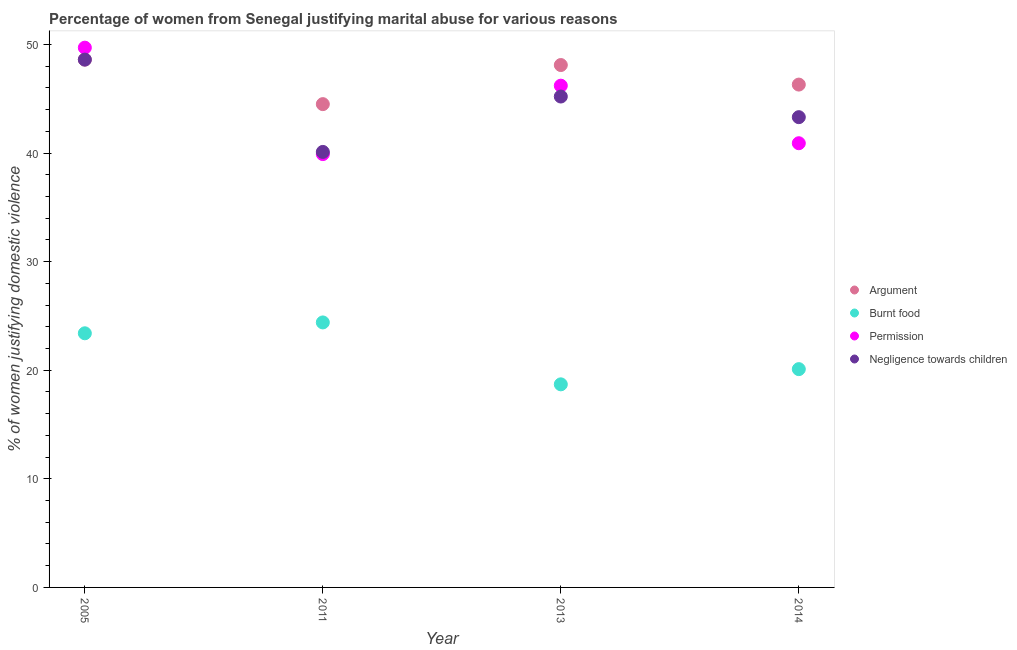What is the percentage of women justifying abuse in the case of an argument in 2011?
Provide a short and direct response. 44.5. Across all years, what is the maximum percentage of women justifying abuse for showing negligence towards children?
Provide a short and direct response. 48.6. Across all years, what is the minimum percentage of women justifying abuse in the case of an argument?
Offer a terse response. 44.5. In which year was the percentage of women justifying abuse for showing negligence towards children minimum?
Keep it short and to the point. 2011. What is the total percentage of women justifying abuse for going without permission in the graph?
Your answer should be very brief. 176.7. What is the difference between the percentage of women justifying abuse for going without permission in 2005 and that in 2014?
Keep it short and to the point. 8.8. What is the difference between the percentage of women justifying abuse for going without permission in 2014 and the percentage of women justifying abuse for burning food in 2013?
Offer a terse response. 22.2. What is the average percentage of women justifying abuse for showing negligence towards children per year?
Give a very brief answer. 44.3. In the year 2014, what is the difference between the percentage of women justifying abuse for showing negligence towards children and percentage of women justifying abuse for burning food?
Offer a very short reply. 23.2. What is the ratio of the percentage of women justifying abuse for going without permission in 2013 to that in 2014?
Make the answer very short. 1.13. Is the percentage of women justifying abuse in the case of an argument in 2013 less than that in 2014?
Your response must be concise. No. Is the difference between the percentage of women justifying abuse for showing negligence towards children in 2005 and 2011 greater than the difference between the percentage of women justifying abuse in the case of an argument in 2005 and 2011?
Keep it short and to the point. Yes. What is the difference between the highest and the second highest percentage of women justifying abuse for showing negligence towards children?
Provide a succinct answer. 3.4. Is the sum of the percentage of women justifying abuse in the case of an argument in 2013 and 2014 greater than the maximum percentage of women justifying abuse for showing negligence towards children across all years?
Your answer should be compact. Yes. Is it the case that in every year, the sum of the percentage of women justifying abuse in the case of an argument and percentage of women justifying abuse for showing negligence towards children is greater than the sum of percentage of women justifying abuse for burning food and percentage of women justifying abuse for going without permission?
Your response must be concise. No. Is the percentage of women justifying abuse for showing negligence towards children strictly greater than the percentage of women justifying abuse for going without permission over the years?
Provide a short and direct response. No. Is the percentage of women justifying abuse for showing negligence towards children strictly less than the percentage of women justifying abuse in the case of an argument over the years?
Your answer should be compact. No. How many years are there in the graph?
Offer a very short reply. 4. Are the values on the major ticks of Y-axis written in scientific E-notation?
Provide a short and direct response. No. Does the graph contain grids?
Provide a succinct answer. No. Where does the legend appear in the graph?
Your answer should be very brief. Center right. How are the legend labels stacked?
Provide a short and direct response. Vertical. What is the title of the graph?
Make the answer very short. Percentage of women from Senegal justifying marital abuse for various reasons. Does "International Monetary Fund" appear as one of the legend labels in the graph?
Offer a very short reply. No. What is the label or title of the X-axis?
Your response must be concise. Year. What is the label or title of the Y-axis?
Provide a succinct answer. % of women justifying domestic violence. What is the % of women justifying domestic violence in Argument in 2005?
Ensure brevity in your answer.  48.6. What is the % of women justifying domestic violence in Burnt food in 2005?
Keep it short and to the point. 23.4. What is the % of women justifying domestic violence in Permission in 2005?
Offer a terse response. 49.7. What is the % of women justifying domestic violence of Negligence towards children in 2005?
Give a very brief answer. 48.6. What is the % of women justifying domestic violence of Argument in 2011?
Your answer should be compact. 44.5. What is the % of women justifying domestic violence of Burnt food in 2011?
Your answer should be compact. 24.4. What is the % of women justifying domestic violence of Permission in 2011?
Your answer should be compact. 39.9. What is the % of women justifying domestic violence of Negligence towards children in 2011?
Ensure brevity in your answer.  40.1. What is the % of women justifying domestic violence in Argument in 2013?
Ensure brevity in your answer.  48.1. What is the % of women justifying domestic violence in Permission in 2013?
Your answer should be very brief. 46.2. What is the % of women justifying domestic violence of Negligence towards children in 2013?
Keep it short and to the point. 45.2. What is the % of women justifying domestic violence of Argument in 2014?
Your answer should be very brief. 46.3. What is the % of women justifying domestic violence in Burnt food in 2014?
Provide a short and direct response. 20.1. What is the % of women justifying domestic violence of Permission in 2014?
Your answer should be compact. 40.9. What is the % of women justifying domestic violence in Negligence towards children in 2014?
Your answer should be very brief. 43.3. Across all years, what is the maximum % of women justifying domestic violence of Argument?
Provide a succinct answer. 48.6. Across all years, what is the maximum % of women justifying domestic violence in Burnt food?
Keep it short and to the point. 24.4. Across all years, what is the maximum % of women justifying domestic violence of Permission?
Ensure brevity in your answer.  49.7. Across all years, what is the maximum % of women justifying domestic violence in Negligence towards children?
Provide a short and direct response. 48.6. Across all years, what is the minimum % of women justifying domestic violence of Argument?
Provide a succinct answer. 44.5. Across all years, what is the minimum % of women justifying domestic violence in Burnt food?
Offer a very short reply. 18.7. Across all years, what is the minimum % of women justifying domestic violence in Permission?
Make the answer very short. 39.9. Across all years, what is the minimum % of women justifying domestic violence in Negligence towards children?
Ensure brevity in your answer.  40.1. What is the total % of women justifying domestic violence in Argument in the graph?
Keep it short and to the point. 187.5. What is the total % of women justifying domestic violence of Burnt food in the graph?
Your response must be concise. 86.6. What is the total % of women justifying domestic violence of Permission in the graph?
Your answer should be compact. 176.7. What is the total % of women justifying domestic violence of Negligence towards children in the graph?
Keep it short and to the point. 177.2. What is the difference between the % of women justifying domestic violence of Argument in 2005 and that in 2011?
Keep it short and to the point. 4.1. What is the difference between the % of women justifying domestic violence in Permission in 2005 and that in 2011?
Make the answer very short. 9.8. What is the difference between the % of women justifying domestic violence of Burnt food in 2005 and that in 2013?
Ensure brevity in your answer.  4.7. What is the difference between the % of women justifying domestic violence of Permission in 2005 and that in 2013?
Provide a short and direct response. 3.5. What is the difference between the % of women justifying domestic violence in Argument in 2005 and that in 2014?
Your answer should be very brief. 2.3. What is the difference between the % of women justifying domestic violence in Negligence towards children in 2005 and that in 2014?
Your response must be concise. 5.3. What is the difference between the % of women justifying domestic violence of Argument in 2011 and that in 2013?
Offer a terse response. -3.6. What is the difference between the % of women justifying domestic violence of Burnt food in 2011 and that in 2013?
Provide a short and direct response. 5.7. What is the difference between the % of women justifying domestic violence in Permission in 2011 and that in 2013?
Offer a very short reply. -6.3. What is the difference between the % of women justifying domestic violence in Negligence towards children in 2011 and that in 2013?
Keep it short and to the point. -5.1. What is the difference between the % of women justifying domestic violence of Negligence towards children in 2011 and that in 2014?
Provide a succinct answer. -3.2. What is the difference between the % of women justifying domestic violence in Argument in 2005 and the % of women justifying domestic violence in Burnt food in 2011?
Make the answer very short. 24.2. What is the difference between the % of women justifying domestic violence in Argument in 2005 and the % of women justifying domestic violence in Negligence towards children in 2011?
Offer a very short reply. 8.5. What is the difference between the % of women justifying domestic violence in Burnt food in 2005 and the % of women justifying domestic violence in Permission in 2011?
Make the answer very short. -16.5. What is the difference between the % of women justifying domestic violence in Burnt food in 2005 and the % of women justifying domestic violence in Negligence towards children in 2011?
Provide a short and direct response. -16.7. What is the difference between the % of women justifying domestic violence of Permission in 2005 and the % of women justifying domestic violence of Negligence towards children in 2011?
Make the answer very short. 9.6. What is the difference between the % of women justifying domestic violence of Argument in 2005 and the % of women justifying domestic violence of Burnt food in 2013?
Your answer should be very brief. 29.9. What is the difference between the % of women justifying domestic violence of Argument in 2005 and the % of women justifying domestic violence of Permission in 2013?
Keep it short and to the point. 2.4. What is the difference between the % of women justifying domestic violence in Burnt food in 2005 and the % of women justifying domestic violence in Permission in 2013?
Ensure brevity in your answer.  -22.8. What is the difference between the % of women justifying domestic violence of Burnt food in 2005 and the % of women justifying domestic violence of Negligence towards children in 2013?
Provide a succinct answer. -21.8. What is the difference between the % of women justifying domestic violence in Permission in 2005 and the % of women justifying domestic violence in Negligence towards children in 2013?
Make the answer very short. 4.5. What is the difference between the % of women justifying domestic violence of Argument in 2005 and the % of women justifying domestic violence of Permission in 2014?
Offer a very short reply. 7.7. What is the difference between the % of women justifying domestic violence in Burnt food in 2005 and the % of women justifying domestic violence in Permission in 2014?
Give a very brief answer. -17.5. What is the difference between the % of women justifying domestic violence in Burnt food in 2005 and the % of women justifying domestic violence in Negligence towards children in 2014?
Your answer should be compact. -19.9. What is the difference between the % of women justifying domestic violence of Argument in 2011 and the % of women justifying domestic violence of Burnt food in 2013?
Offer a terse response. 25.8. What is the difference between the % of women justifying domestic violence in Argument in 2011 and the % of women justifying domestic violence in Permission in 2013?
Provide a succinct answer. -1.7. What is the difference between the % of women justifying domestic violence in Argument in 2011 and the % of women justifying domestic violence in Negligence towards children in 2013?
Make the answer very short. -0.7. What is the difference between the % of women justifying domestic violence of Burnt food in 2011 and the % of women justifying domestic violence of Permission in 2013?
Make the answer very short. -21.8. What is the difference between the % of women justifying domestic violence in Burnt food in 2011 and the % of women justifying domestic violence in Negligence towards children in 2013?
Make the answer very short. -20.8. What is the difference between the % of women justifying domestic violence of Argument in 2011 and the % of women justifying domestic violence of Burnt food in 2014?
Ensure brevity in your answer.  24.4. What is the difference between the % of women justifying domestic violence in Argument in 2011 and the % of women justifying domestic violence in Permission in 2014?
Your response must be concise. 3.6. What is the difference between the % of women justifying domestic violence of Argument in 2011 and the % of women justifying domestic violence of Negligence towards children in 2014?
Provide a succinct answer. 1.2. What is the difference between the % of women justifying domestic violence in Burnt food in 2011 and the % of women justifying domestic violence in Permission in 2014?
Offer a terse response. -16.5. What is the difference between the % of women justifying domestic violence of Burnt food in 2011 and the % of women justifying domestic violence of Negligence towards children in 2014?
Ensure brevity in your answer.  -18.9. What is the difference between the % of women justifying domestic violence of Permission in 2011 and the % of women justifying domestic violence of Negligence towards children in 2014?
Offer a terse response. -3.4. What is the difference between the % of women justifying domestic violence in Burnt food in 2013 and the % of women justifying domestic violence in Permission in 2014?
Ensure brevity in your answer.  -22.2. What is the difference between the % of women justifying domestic violence in Burnt food in 2013 and the % of women justifying domestic violence in Negligence towards children in 2014?
Make the answer very short. -24.6. What is the average % of women justifying domestic violence of Argument per year?
Provide a short and direct response. 46.88. What is the average % of women justifying domestic violence of Burnt food per year?
Provide a short and direct response. 21.65. What is the average % of women justifying domestic violence in Permission per year?
Give a very brief answer. 44.17. What is the average % of women justifying domestic violence in Negligence towards children per year?
Offer a very short reply. 44.3. In the year 2005, what is the difference between the % of women justifying domestic violence in Argument and % of women justifying domestic violence in Burnt food?
Your answer should be compact. 25.2. In the year 2005, what is the difference between the % of women justifying domestic violence in Argument and % of women justifying domestic violence in Negligence towards children?
Offer a very short reply. 0. In the year 2005, what is the difference between the % of women justifying domestic violence of Burnt food and % of women justifying domestic violence of Permission?
Your response must be concise. -26.3. In the year 2005, what is the difference between the % of women justifying domestic violence in Burnt food and % of women justifying domestic violence in Negligence towards children?
Ensure brevity in your answer.  -25.2. In the year 2005, what is the difference between the % of women justifying domestic violence in Permission and % of women justifying domestic violence in Negligence towards children?
Ensure brevity in your answer.  1.1. In the year 2011, what is the difference between the % of women justifying domestic violence in Argument and % of women justifying domestic violence in Burnt food?
Make the answer very short. 20.1. In the year 2011, what is the difference between the % of women justifying domestic violence of Argument and % of women justifying domestic violence of Permission?
Give a very brief answer. 4.6. In the year 2011, what is the difference between the % of women justifying domestic violence in Burnt food and % of women justifying domestic violence in Permission?
Make the answer very short. -15.5. In the year 2011, what is the difference between the % of women justifying domestic violence in Burnt food and % of women justifying domestic violence in Negligence towards children?
Offer a terse response. -15.7. In the year 2011, what is the difference between the % of women justifying domestic violence of Permission and % of women justifying domestic violence of Negligence towards children?
Your answer should be compact. -0.2. In the year 2013, what is the difference between the % of women justifying domestic violence in Argument and % of women justifying domestic violence in Burnt food?
Keep it short and to the point. 29.4. In the year 2013, what is the difference between the % of women justifying domestic violence of Argument and % of women justifying domestic violence of Negligence towards children?
Keep it short and to the point. 2.9. In the year 2013, what is the difference between the % of women justifying domestic violence of Burnt food and % of women justifying domestic violence of Permission?
Provide a succinct answer. -27.5. In the year 2013, what is the difference between the % of women justifying domestic violence of Burnt food and % of women justifying domestic violence of Negligence towards children?
Give a very brief answer. -26.5. In the year 2014, what is the difference between the % of women justifying domestic violence in Argument and % of women justifying domestic violence in Burnt food?
Keep it short and to the point. 26.2. In the year 2014, what is the difference between the % of women justifying domestic violence in Argument and % of women justifying domestic violence in Permission?
Give a very brief answer. 5.4. In the year 2014, what is the difference between the % of women justifying domestic violence of Argument and % of women justifying domestic violence of Negligence towards children?
Provide a short and direct response. 3. In the year 2014, what is the difference between the % of women justifying domestic violence in Burnt food and % of women justifying domestic violence in Permission?
Give a very brief answer. -20.8. In the year 2014, what is the difference between the % of women justifying domestic violence of Burnt food and % of women justifying domestic violence of Negligence towards children?
Ensure brevity in your answer.  -23.2. In the year 2014, what is the difference between the % of women justifying domestic violence of Permission and % of women justifying domestic violence of Negligence towards children?
Your answer should be compact. -2.4. What is the ratio of the % of women justifying domestic violence in Argument in 2005 to that in 2011?
Give a very brief answer. 1.09. What is the ratio of the % of women justifying domestic violence of Burnt food in 2005 to that in 2011?
Your answer should be compact. 0.96. What is the ratio of the % of women justifying domestic violence in Permission in 2005 to that in 2011?
Keep it short and to the point. 1.25. What is the ratio of the % of women justifying domestic violence of Negligence towards children in 2005 to that in 2011?
Keep it short and to the point. 1.21. What is the ratio of the % of women justifying domestic violence in Argument in 2005 to that in 2013?
Ensure brevity in your answer.  1.01. What is the ratio of the % of women justifying domestic violence of Burnt food in 2005 to that in 2013?
Give a very brief answer. 1.25. What is the ratio of the % of women justifying domestic violence in Permission in 2005 to that in 2013?
Your answer should be compact. 1.08. What is the ratio of the % of women justifying domestic violence of Negligence towards children in 2005 to that in 2013?
Make the answer very short. 1.08. What is the ratio of the % of women justifying domestic violence in Argument in 2005 to that in 2014?
Your answer should be very brief. 1.05. What is the ratio of the % of women justifying domestic violence of Burnt food in 2005 to that in 2014?
Make the answer very short. 1.16. What is the ratio of the % of women justifying domestic violence in Permission in 2005 to that in 2014?
Offer a terse response. 1.22. What is the ratio of the % of women justifying domestic violence in Negligence towards children in 2005 to that in 2014?
Your answer should be very brief. 1.12. What is the ratio of the % of women justifying domestic violence in Argument in 2011 to that in 2013?
Your response must be concise. 0.93. What is the ratio of the % of women justifying domestic violence in Burnt food in 2011 to that in 2013?
Keep it short and to the point. 1.3. What is the ratio of the % of women justifying domestic violence of Permission in 2011 to that in 2013?
Keep it short and to the point. 0.86. What is the ratio of the % of women justifying domestic violence of Negligence towards children in 2011 to that in 2013?
Ensure brevity in your answer.  0.89. What is the ratio of the % of women justifying domestic violence of Argument in 2011 to that in 2014?
Offer a terse response. 0.96. What is the ratio of the % of women justifying domestic violence of Burnt food in 2011 to that in 2014?
Provide a short and direct response. 1.21. What is the ratio of the % of women justifying domestic violence in Permission in 2011 to that in 2014?
Provide a succinct answer. 0.98. What is the ratio of the % of women justifying domestic violence in Negligence towards children in 2011 to that in 2014?
Offer a very short reply. 0.93. What is the ratio of the % of women justifying domestic violence of Argument in 2013 to that in 2014?
Provide a short and direct response. 1.04. What is the ratio of the % of women justifying domestic violence of Burnt food in 2013 to that in 2014?
Your response must be concise. 0.93. What is the ratio of the % of women justifying domestic violence in Permission in 2013 to that in 2014?
Your answer should be very brief. 1.13. What is the ratio of the % of women justifying domestic violence in Negligence towards children in 2013 to that in 2014?
Your response must be concise. 1.04. What is the difference between the highest and the second highest % of women justifying domestic violence of Burnt food?
Your answer should be compact. 1. What is the difference between the highest and the lowest % of women justifying domestic violence of Argument?
Offer a terse response. 4.1. What is the difference between the highest and the lowest % of women justifying domestic violence in Permission?
Your response must be concise. 9.8. What is the difference between the highest and the lowest % of women justifying domestic violence of Negligence towards children?
Provide a short and direct response. 8.5. 